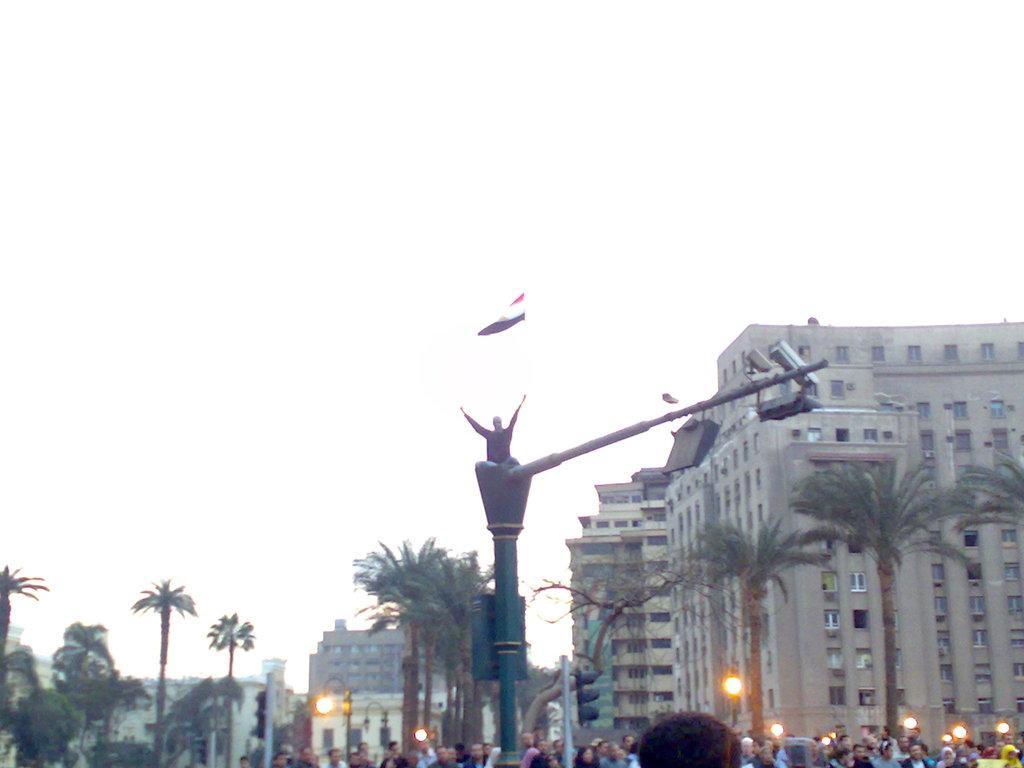Could you give a brief overview of what you see in this image? In this image we can see the board and lights to the pole. Here we can see the statue, flag, traffic signal poles, light poles, people standing here, trees, buildings and the sky in the background. 